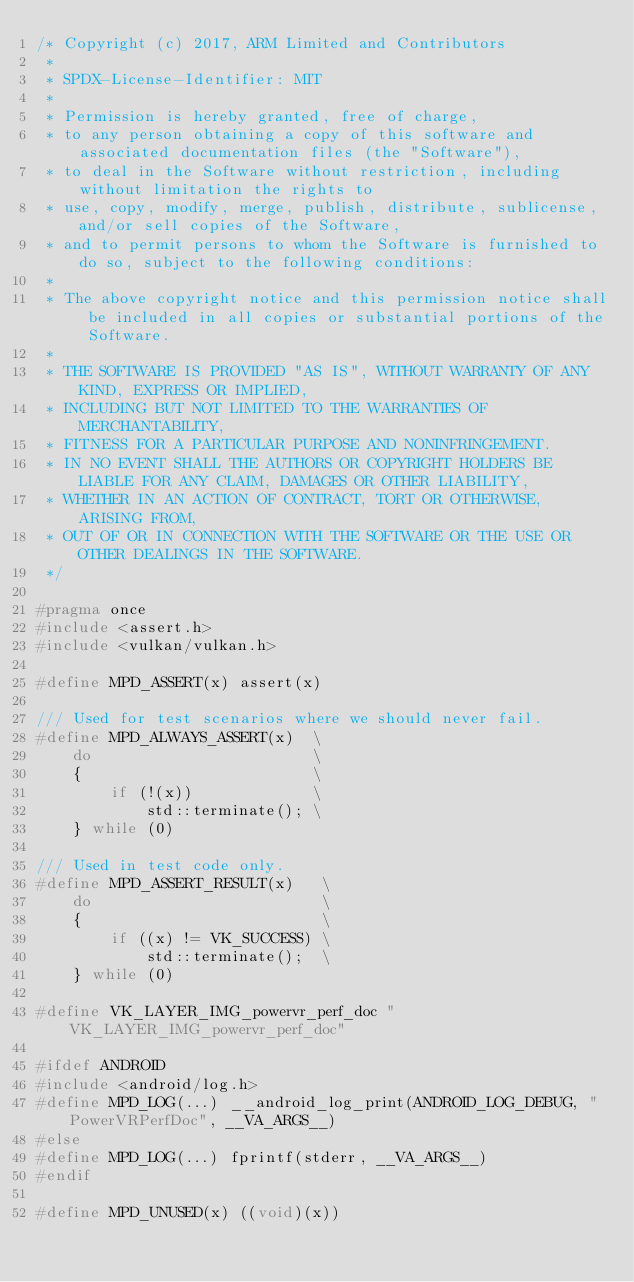<code> <loc_0><loc_0><loc_500><loc_500><_C++_>/* Copyright (c) 2017, ARM Limited and Contributors
 *
 * SPDX-License-Identifier: MIT
 *
 * Permission is hereby granted, free of charge,
 * to any person obtaining a copy of this software and associated documentation files (the "Software"),
 * to deal in the Software without restriction, including without limitation the rights to
 * use, copy, modify, merge, publish, distribute, sublicense, and/or sell copies of the Software,
 * and to permit persons to whom the Software is furnished to do so, subject to the following conditions:
 *
 * The above copyright notice and this permission notice shall be included in all copies or substantial portions of the Software.
 *
 * THE SOFTWARE IS PROVIDED "AS IS", WITHOUT WARRANTY OF ANY KIND, EXPRESS OR IMPLIED,
 * INCLUDING BUT NOT LIMITED TO THE WARRANTIES OF MERCHANTABILITY,
 * FITNESS FOR A PARTICULAR PURPOSE AND NONINFRINGEMENT.
 * IN NO EVENT SHALL THE AUTHORS OR COPYRIGHT HOLDERS BE LIABLE FOR ANY CLAIM, DAMAGES OR OTHER LIABILITY,
 * WHETHER IN AN ACTION OF CONTRACT, TORT OR OTHERWISE, ARISING FROM,
 * OUT OF OR IN CONNECTION WITH THE SOFTWARE OR THE USE OR OTHER DEALINGS IN THE SOFTWARE.
 */

#pragma once
#include <assert.h>
#include <vulkan/vulkan.h>

#define MPD_ASSERT(x) assert(x)

/// Used for test scenarios where we should never fail.
#define MPD_ALWAYS_ASSERT(x)  \
	do                        \
	{                         \
		if (!(x))             \
			std::terminate(); \
	} while (0)

/// Used in test code only.
#define MPD_ASSERT_RESULT(x)   \
	do                         \
	{                          \
		if ((x) != VK_SUCCESS) \
			std::terminate();  \
	} while (0)

#define VK_LAYER_IMG_powervr_perf_doc "VK_LAYER_IMG_powervr_perf_doc"

#ifdef ANDROID
#include <android/log.h>
#define MPD_LOG(...) __android_log_print(ANDROID_LOG_DEBUG, "PowerVRPerfDoc", __VA_ARGS__)
#else
#define MPD_LOG(...) fprintf(stderr, __VA_ARGS__)
#endif

#define MPD_UNUSED(x) ((void)(x))
</code> 